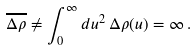<formula> <loc_0><loc_0><loc_500><loc_500>\overline { \Delta \rho } \neq \int _ { 0 } ^ { \infty } d u ^ { 2 } \, \Delta \rho ( u ) = \infty \, .</formula> 